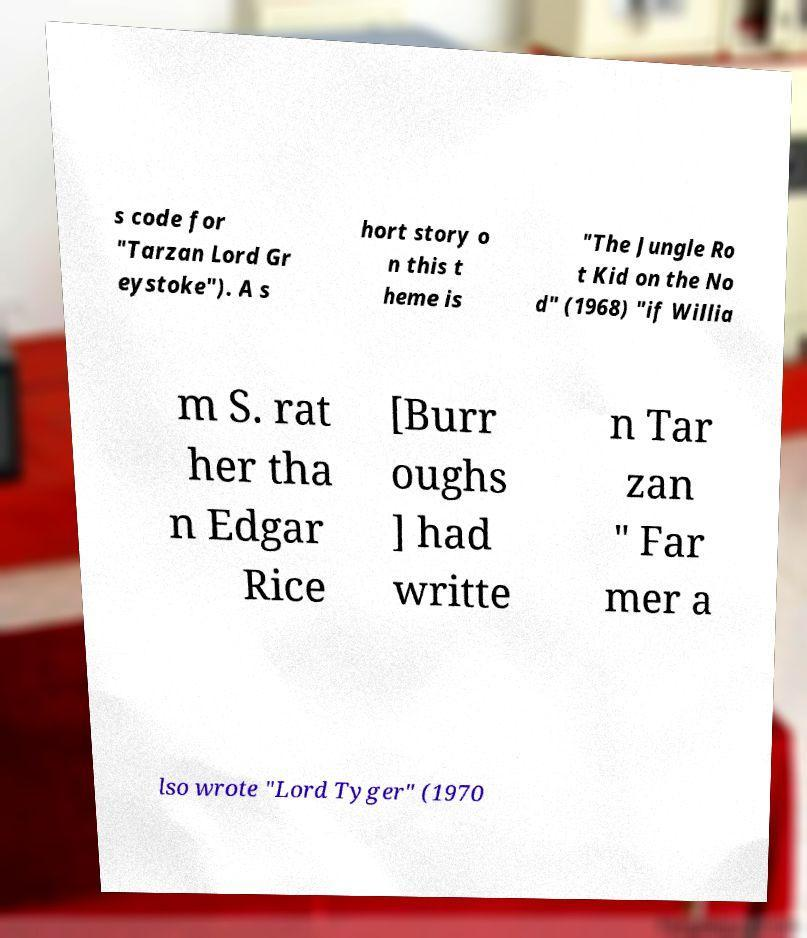Please identify and transcribe the text found in this image. s code for "Tarzan Lord Gr eystoke"). A s hort story o n this t heme is "The Jungle Ro t Kid on the No d" (1968) "if Willia m S. rat her tha n Edgar Rice [Burr oughs ] had writte n Tar zan " Far mer a lso wrote "Lord Tyger" (1970 